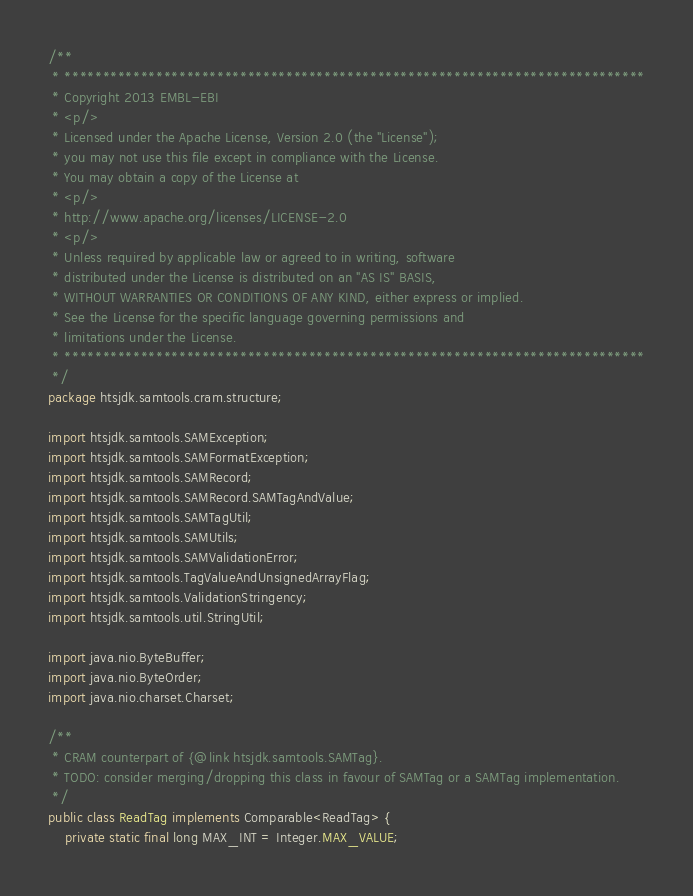Convert code to text. <code><loc_0><loc_0><loc_500><loc_500><_Java_>/**
 * ****************************************************************************
 * Copyright 2013 EMBL-EBI
 * <p/>
 * Licensed under the Apache License, Version 2.0 (the "License");
 * you may not use this file except in compliance with the License.
 * You may obtain a copy of the License at
 * <p/>
 * http://www.apache.org/licenses/LICENSE-2.0
 * <p/>
 * Unless required by applicable law or agreed to in writing, software
 * distributed under the License is distributed on an "AS IS" BASIS,
 * WITHOUT WARRANTIES OR CONDITIONS OF ANY KIND, either express or implied.
 * See the License for the specific language governing permissions and
 * limitations under the License.
 * ****************************************************************************
 */
package htsjdk.samtools.cram.structure;

import htsjdk.samtools.SAMException;
import htsjdk.samtools.SAMFormatException;
import htsjdk.samtools.SAMRecord;
import htsjdk.samtools.SAMRecord.SAMTagAndValue;
import htsjdk.samtools.SAMTagUtil;
import htsjdk.samtools.SAMUtils;
import htsjdk.samtools.SAMValidationError;
import htsjdk.samtools.TagValueAndUnsignedArrayFlag;
import htsjdk.samtools.ValidationStringency;
import htsjdk.samtools.util.StringUtil;

import java.nio.ByteBuffer;
import java.nio.ByteOrder;
import java.nio.charset.Charset;

/**
 * CRAM counterpart of {@link htsjdk.samtools.SAMTag}.
 * TODO: consider merging/dropping this class in favour of SAMTag or a SAMTag implementation.
 */
public class ReadTag implements Comparable<ReadTag> {
    private static final long MAX_INT = Integer.MAX_VALUE;</code> 